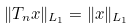<formula> <loc_0><loc_0><loc_500><loc_500>\| T _ { n } x \| _ { L _ { 1 } } = \| x \| _ { L _ { 1 } }</formula> 